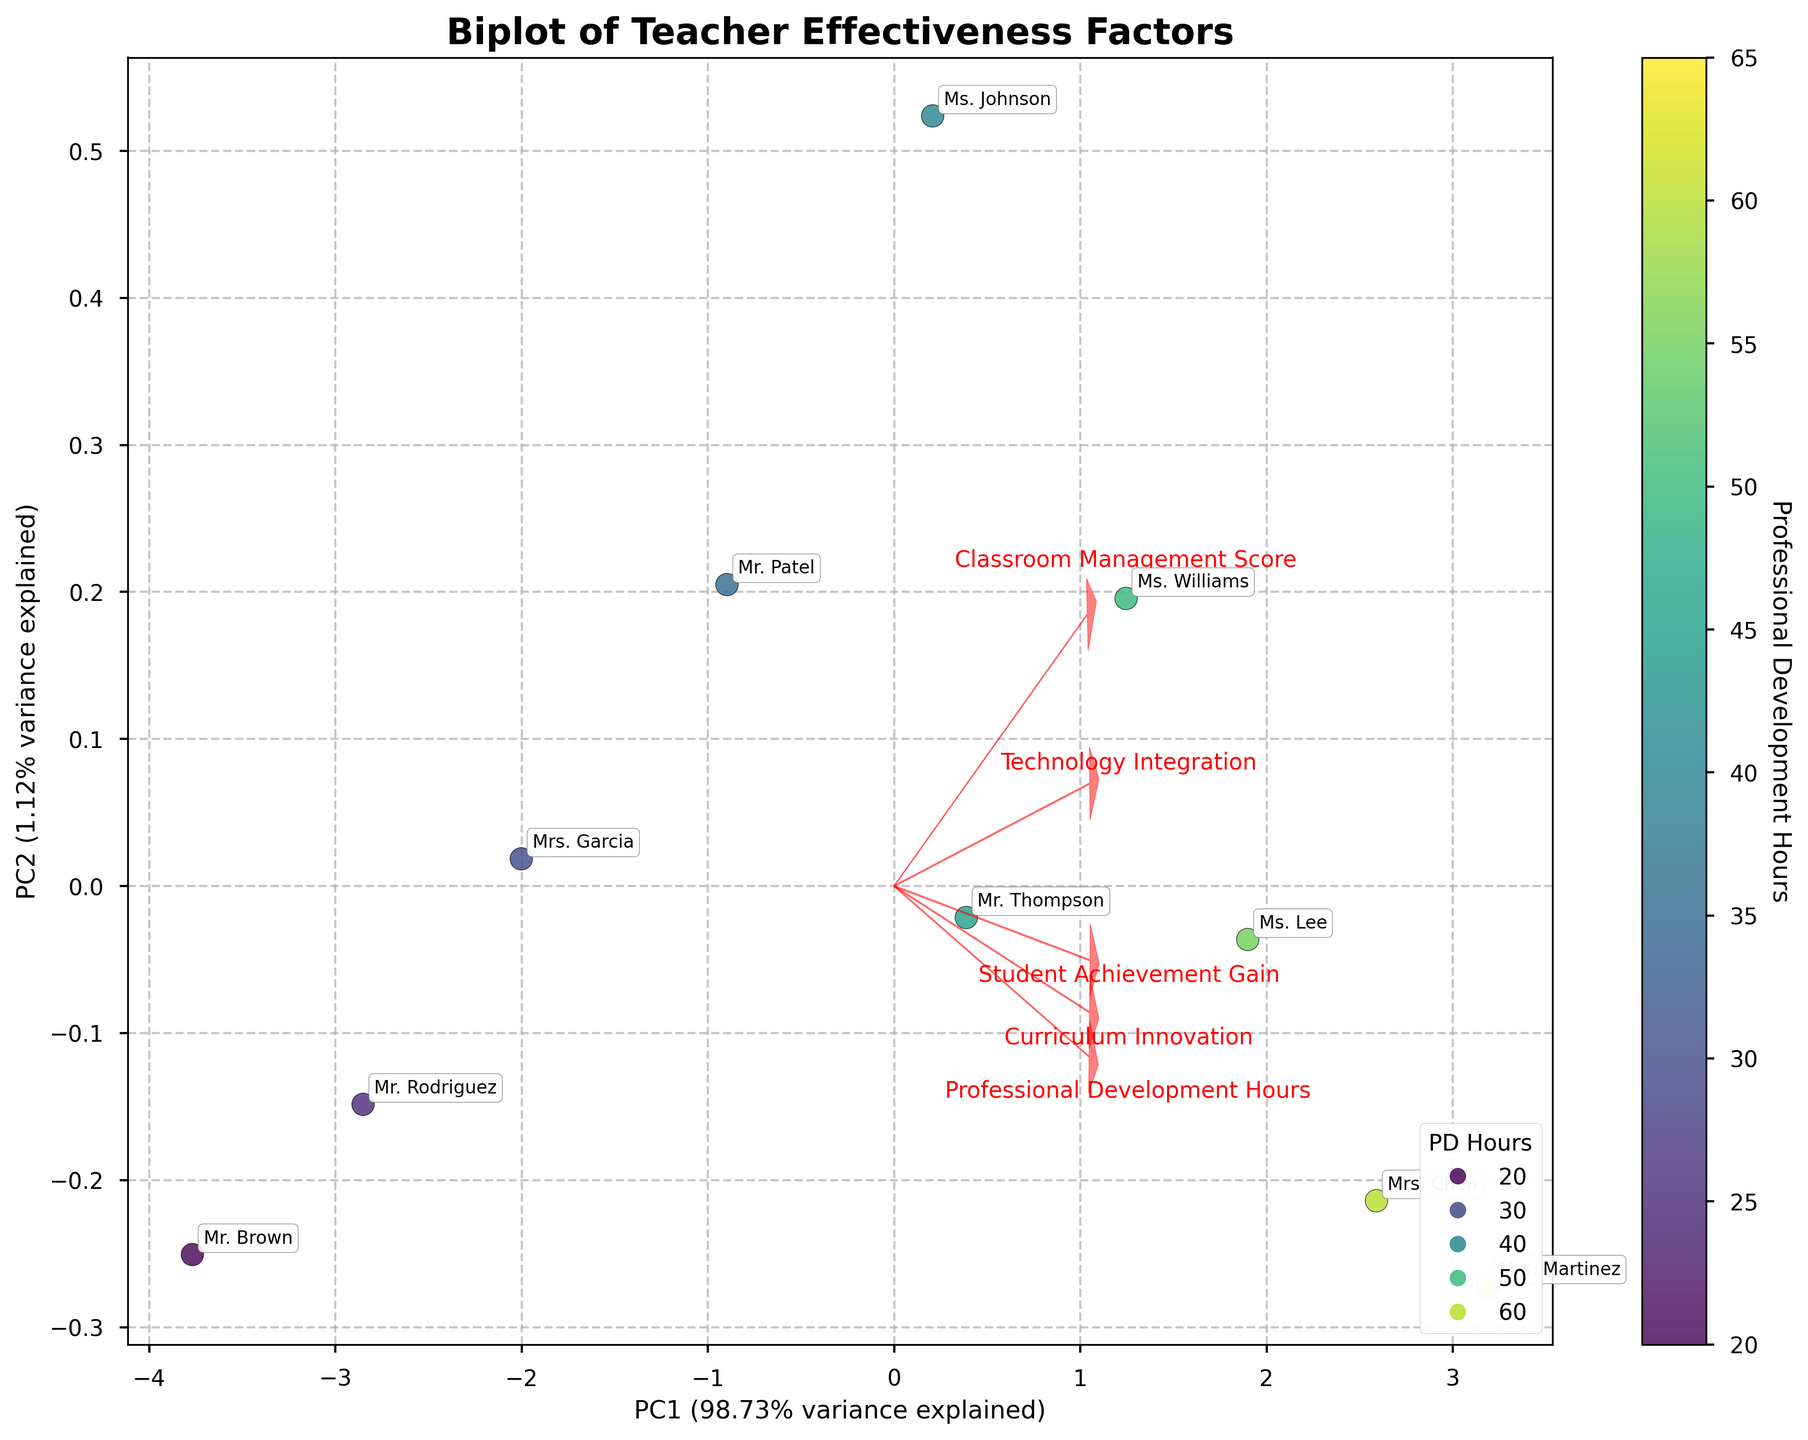What does the color represent in this biplot? The color of each data point in the biplot represents the number of Professional Development Hours for each teacher. This can be inferred because there is a colorbar labeled 'Professional Development Hours' next to the plot.
Answer: Professional Development Hours Which teacher has the highest Student Achievement Gain? To determine the teacher with the highest Student Achievement Gain, look for the point on the biplot that is associated with the highest position along the arrow corresponding to 'Student Achievement Gain'. The teacher Mrs. Martinez has a notable data point aligned with high Student Achievement Gain.
Answer: Mrs. Martinez How much variance is explained by the first principal component (PC1)? The label on the x-axis of the biplot indicates the variance explained by PC1. The label reads 'PC1 (XX.XX% variance explained)'. Based on this information, we can see the percentage value directly.
Answer: 52.93% Which two features have the most similar loading vector directions? To determine which features have the most similar loading vector directions, we look at the arrows in the biplot and find the ones that point in nearly the same direction. In this case, 'Classroom Management Score' and 'Curriculum Innovation' have arrows that are almost parallel, indicating similar loading vector directions.
Answer: Classroom Management Score and Curriculum Innovation Compare the Professional Development Hours for Mr. Rodriguez and Ms. Williams based on the biplot. Which teacher attended more hours? To compare the Professional Development Hours for these teachers, locate their corresponding scatter points on the biplot and reference the color that corresponds to the colorbar. Ms. Williams' point appears in a color corresponding to higher Professional Development Hours compared to Mr. Rodriguez's.
Answer: Ms. Williams For which feature does Ms. Lee have alignment showing strength? Look for Ms. Lee's data point position relative to the feature loading vectors. Her point aligns closely with the 'Student Achievement Gain' vector, indicating strength in this feature.
Answer: Student Achievement Gain How do Technology Integration scores differ between Mr. Brown and Mrs. Chen? To discern this, identify Mr. Brown and Mrs. Chen's data points and observe their positions relative to the 'Technology Integration' arrow. Mrs. Chen's data point is further along the 'Technology Integration' vector, indicating she has a higher score.
Answer: Mrs. Chen What is the approximate position of Mr. Patel on the PC2 axis? Locate Mr. Patel's data point and refer to its position along the y-axis (PC2). Mr. Patel's point is centered around a slightly positive y-value.
Answer: Slightly positive Which feature correlates most strongly with the first principal component (PC1)? The strength of correlation is indicated by the length of the arrows pointing from the origin to the feature labels. The longest arrow along PC1 represents the feature with the strongest correlation. 'Student Achievement Gain' has the longest arrow on PC1.
Answer: Student Achievement Gain Is there a noticeable trend between Professional Development Hours and Curriculum Innovation? To find the trend, observe the clustering of data points and their alignment with the 'Curriculum Innovation' loading vector. There is a slight trend where higher Professional Development Hours (based on color and position) appear to align with higher Curriculum Innovation.
Answer: Yes 